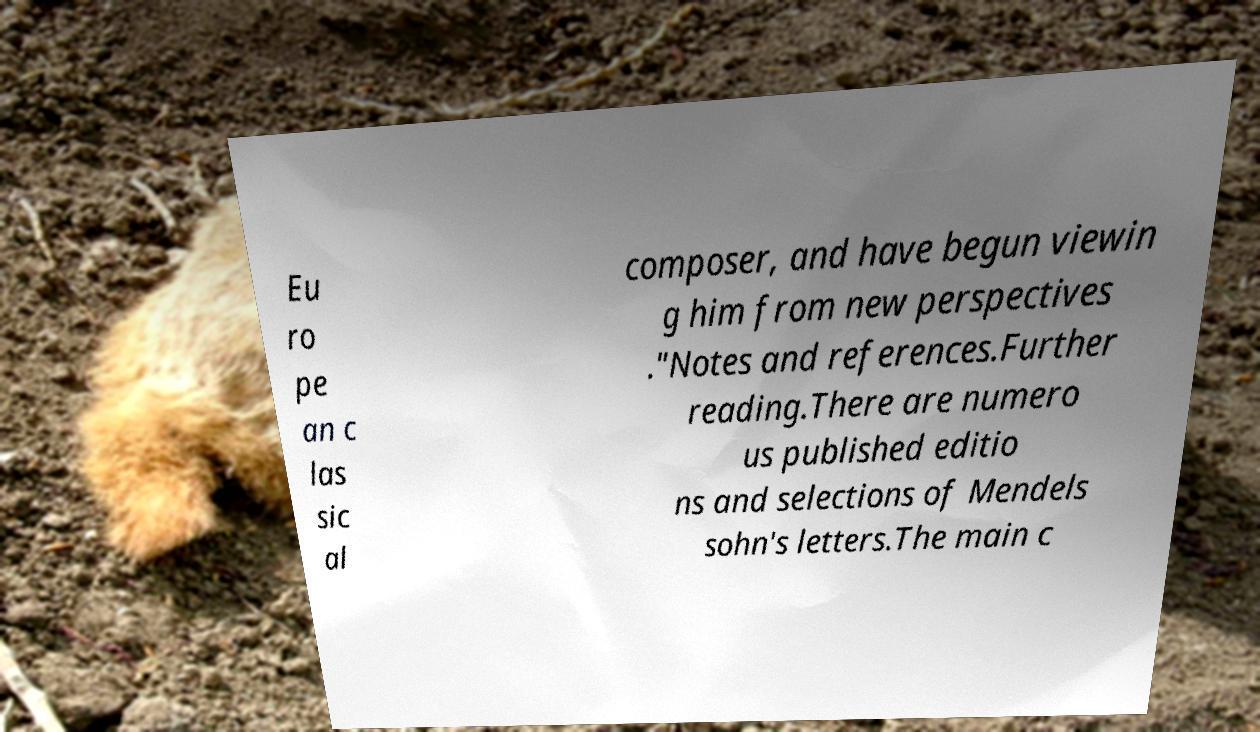Please read and relay the text visible in this image. What does it say? Eu ro pe an c las sic al composer, and have begun viewin g him from new perspectives ."Notes and references.Further reading.There are numero us published editio ns and selections of Mendels sohn's letters.The main c 